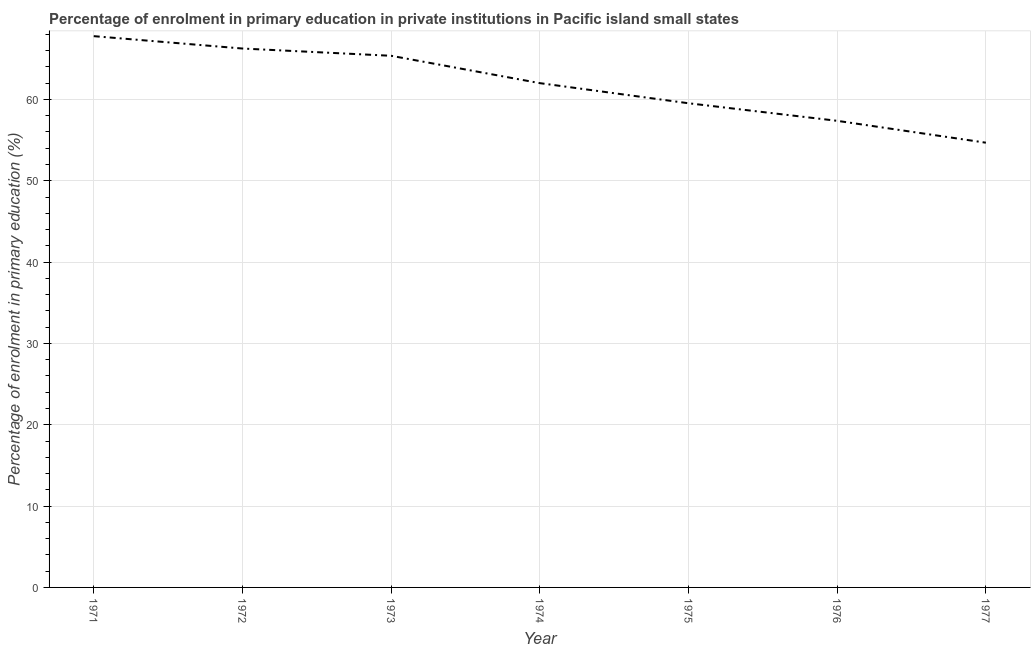What is the enrolment percentage in primary education in 1975?
Provide a short and direct response. 59.53. Across all years, what is the maximum enrolment percentage in primary education?
Provide a succinct answer. 67.78. Across all years, what is the minimum enrolment percentage in primary education?
Provide a short and direct response. 54.68. In which year was the enrolment percentage in primary education maximum?
Your answer should be compact. 1971. What is the sum of the enrolment percentage in primary education?
Provide a succinct answer. 432.99. What is the difference between the enrolment percentage in primary education in 1975 and 1977?
Offer a very short reply. 4.85. What is the average enrolment percentage in primary education per year?
Give a very brief answer. 61.86. What is the median enrolment percentage in primary education?
Provide a succinct answer. 62. Do a majority of the years between 1974 and 1976 (inclusive) have enrolment percentage in primary education greater than 32 %?
Provide a short and direct response. Yes. What is the ratio of the enrolment percentage in primary education in 1972 to that in 1975?
Your answer should be compact. 1.11. Is the enrolment percentage in primary education in 1971 less than that in 1974?
Provide a succinct answer. No. Is the difference between the enrolment percentage in primary education in 1972 and 1975 greater than the difference between any two years?
Make the answer very short. No. What is the difference between the highest and the second highest enrolment percentage in primary education?
Ensure brevity in your answer.  1.52. Is the sum of the enrolment percentage in primary education in 1974 and 1977 greater than the maximum enrolment percentage in primary education across all years?
Provide a succinct answer. Yes. What is the difference between the highest and the lowest enrolment percentage in primary education?
Make the answer very short. 13.1. Does the enrolment percentage in primary education monotonically increase over the years?
Offer a terse response. No. How many lines are there?
Your response must be concise. 1. How many years are there in the graph?
Keep it short and to the point. 7. What is the difference between two consecutive major ticks on the Y-axis?
Make the answer very short. 10. Are the values on the major ticks of Y-axis written in scientific E-notation?
Provide a short and direct response. No. What is the title of the graph?
Give a very brief answer. Percentage of enrolment in primary education in private institutions in Pacific island small states. What is the label or title of the Y-axis?
Keep it short and to the point. Percentage of enrolment in primary education (%). What is the Percentage of enrolment in primary education (%) in 1971?
Offer a terse response. 67.78. What is the Percentage of enrolment in primary education (%) of 1972?
Offer a very short reply. 66.26. What is the Percentage of enrolment in primary education (%) in 1973?
Provide a short and direct response. 65.37. What is the Percentage of enrolment in primary education (%) of 1974?
Your answer should be very brief. 62. What is the Percentage of enrolment in primary education (%) of 1975?
Offer a very short reply. 59.53. What is the Percentage of enrolment in primary education (%) of 1976?
Give a very brief answer. 57.37. What is the Percentage of enrolment in primary education (%) of 1977?
Give a very brief answer. 54.68. What is the difference between the Percentage of enrolment in primary education (%) in 1971 and 1972?
Ensure brevity in your answer.  1.52. What is the difference between the Percentage of enrolment in primary education (%) in 1971 and 1973?
Your response must be concise. 2.41. What is the difference between the Percentage of enrolment in primary education (%) in 1971 and 1974?
Offer a very short reply. 5.78. What is the difference between the Percentage of enrolment in primary education (%) in 1971 and 1975?
Your response must be concise. 8.25. What is the difference between the Percentage of enrolment in primary education (%) in 1971 and 1976?
Keep it short and to the point. 10.41. What is the difference between the Percentage of enrolment in primary education (%) in 1971 and 1977?
Ensure brevity in your answer.  13.1. What is the difference between the Percentage of enrolment in primary education (%) in 1972 and 1973?
Your answer should be compact. 0.89. What is the difference between the Percentage of enrolment in primary education (%) in 1972 and 1974?
Keep it short and to the point. 4.26. What is the difference between the Percentage of enrolment in primary education (%) in 1972 and 1975?
Provide a succinct answer. 6.73. What is the difference between the Percentage of enrolment in primary education (%) in 1972 and 1976?
Make the answer very short. 8.89. What is the difference between the Percentage of enrolment in primary education (%) in 1972 and 1977?
Ensure brevity in your answer.  11.58. What is the difference between the Percentage of enrolment in primary education (%) in 1973 and 1974?
Provide a short and direct response. 3.36. What is the difference between the Percentage of enrolment in primary education (%) in 1973 and 1975?
Offer a very short reply. 5.84. What is the difference between the Percentage of enrolment in primary education (%) in 1973 and 1976?
Ensure brevity in your answer.  8. What is the difference between the Percentage of enrolment in primary education (%) in 1973 and 1977?
Provide a succinct answer. 10.69. What is the difference between the Percentage of enrolment in primary education (%) in 1974 and 1975?
Your response must be concise. 2.47. What is the difference between the Percentage of enrolment in primary education (%) in 1974 and 1976?
Give a very brief answer. 4.63. What is the difference between the Percentage of enrolment in primary education (%) in 1974 and 1977?
Keep it short and to the point. 7.32. What is the difference between the Percentage of enrolment in primary education (%) in 1975 and 1976?
Make the answer very short. 2.16. What is the difference between the Percentage of enrolment in primary education (%) in 1975 and 1977?
Make the answer very short. 4.85. What is the difference between the Percentage of enrolment in primary education (%) in 1976 and 1977?
Your answer should be compact. 2.69. What is the ratio of the Percentage of enrolment in primary education (%) in 1971 to that in 1973?
Your answer should be very brief. 1.04. What is the ratio of the Percentage of enrolment in primary education (%) in 1971 to that in 1974?
Your response must be concise. 1.09. What is the ratio of the Percentage of enrolment in primary education (%) in 1971 to that in 1975?
Offer a terse response. 1.14. What is the ratio of the Percentage of enrolment in primary education (%) in 1971 to that in 1976?
Your response must be concise. 1.18. What is the ratio of the Percentage of enrolment in primary education (%) in 1971 to that in 1977?
Your response must be concise. 1.24. What is the ratio of the Percentage of enrolment in primary education (%) in 1972 to that in 1973?
Offer a very short reply. 1.01. What is the ratio of the Percentage of enrolment in primary education (%) in 1972 to that in 1974?
Make the answer very short. 1.07. What is the ratio of the Percentage of enrolment in primary education (%) in 1972 to that in 1975?
Offer a terse response. 1.11. What is the ratio of the Percentage of enrolment in primary education (%) in 1972 to that in 1976?
Give a very brief answer. 1.16. What is the ratio of the Percentage of enrolment in primary education (%) in 1972 to that in 1977?
Keep it short and to the point. 1.21. What is the ratio of the Percentage of enrolment in primary education (%) in 1973 to that in 1974?
Your answer should be compact. 1.05. What is the ratio of the Percentage of enrolment in primary education (%) in 1973 to that in 1975?
Offer a very short reply. 1.1. What is the ratio of the Percentage of enrolment in primary education (%) in 1973 to that in 1976?
Offer a terse response. 1.14. What is the ratio of the Percentage of enrolment in primary education (%) in 1973 to that in 1977?
Your response must be concise. 1.2. What is the ratio of the Percentage of enrolment in primary education (%) in 1974 to that in 1975?
Ensure brevity in your answer.  1.04. What is the ratio of the Percentage of enrolment in primary education (%) in 1974 to that in 1976?
Your response must be concise. 1.08. What is the ratio of the Percentage of enrolment in primary education (%) in 1974 to that in 1977?
Provide a succinct answer. 1.13. What is the ratio of the Percentage of enrolment in primary education (%) in 1975 to that in 1976?
Offer a very short reply. 1.04. What is the ratio of the Percentage of enrolment in primary education (%) in 1975 to that in 1977?
Ensure brevity in your answer.  1.09. What is the ratio of the Percentage of enrolment in primary education (%) in 1976 to that in 1977?
Offer a terse response. 1.05. 